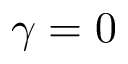Convert formula to latex. <formula><loc_0><loc_0><loc_500><loc_500>\gamma = 0</formula> 